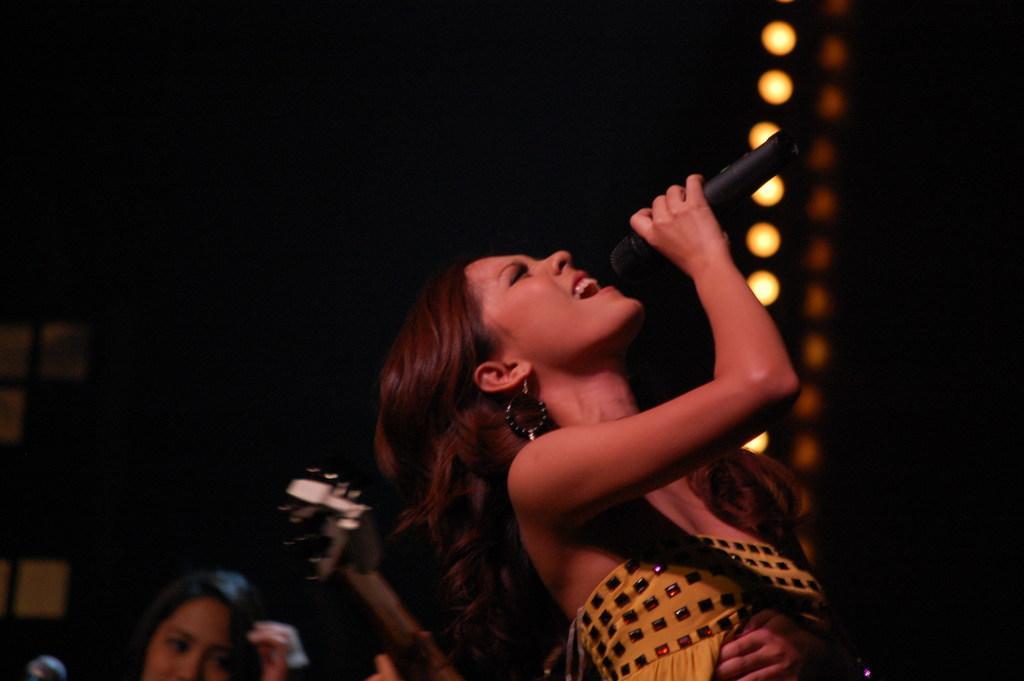Could you give a brief overview of what you see in this image? There is a girl holding microphone and singing in it. 